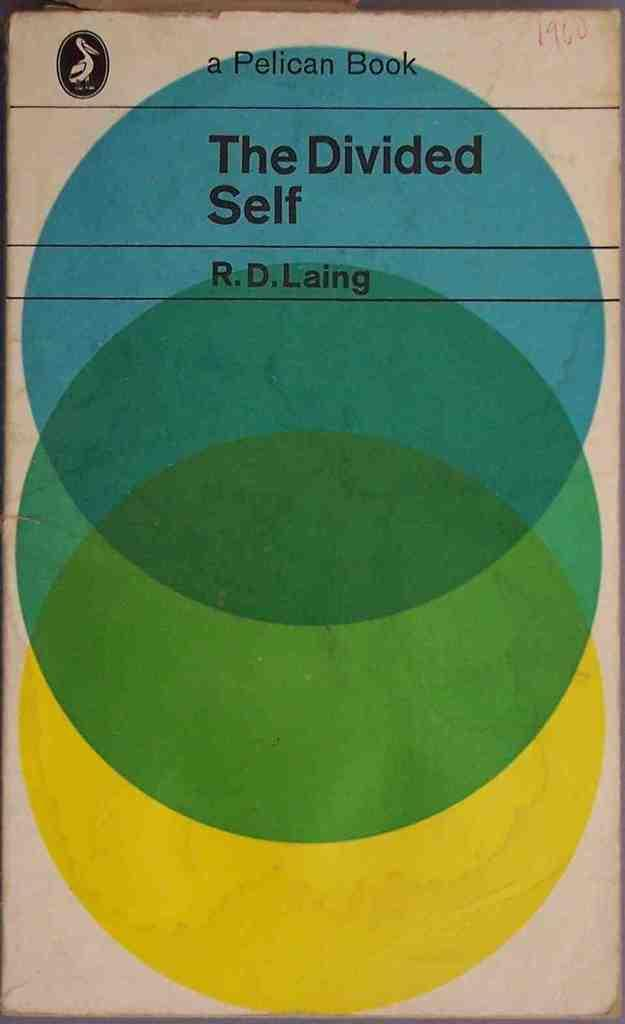<image>
Render a clear and concise summary of the photo. Book titled The Divided Self by R.D. Laing that shows three different colored circles. 